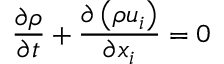Convert formula to latex. <formula><loc_0><loc_0><loc_500><loc_500>\frac { \partial \rho } { \partial t } + \frac { \partial \left ( \rho u _ { i } \right ) } { \partial x _ { i } } = 0</formula> 